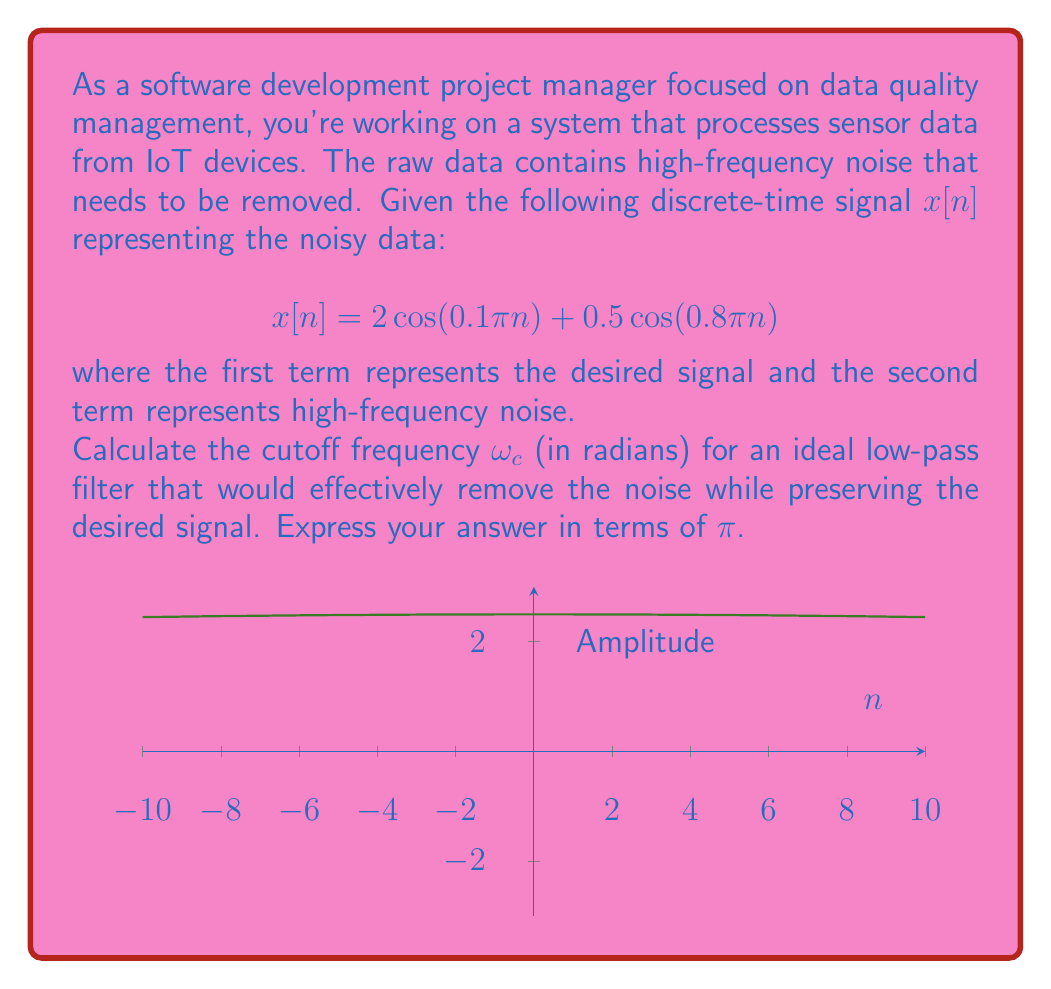What is the answer to this math problem? To solve this problem, we need to follow these steps:

1) Identify the frequencies in the signal:
   - The desired signal has a frequency of $0.1\pi$
   - The noise has a frequency of $0.8\pi$

2) The ideal low-pass filter should allow the lower frequency (desired signal) to pass while blocking the higher frequency (noise).

3) The cutoff frequency $\omega_c$ should be between these two frequencies:

   $$0.1\pi < \omega_c < 0.8\pi$$

4) To ensure we preserve the desired signal and remove the noise, we should choose a cutoff frequency closer to the lower frequency but sufficiently far from the higher frequency.

5) A common practice is to choose the cutoff frequency as the geometric mean of the two frequencies:

   $$\omega_c = \sqrt{(0.1\pi)(0.8\pi)} = \sqrt{0.08\pi^2} = \pi\sqrt{0.08}$$

6) Simplify:
   $$\omega_c = \pi\sqrt{0.08} \approx 0.2827\pi$$

Therefore, a suitable cutoff frequency for the low-pass filter would be approximately $0.2827\pi$ radians.
Answer: $\omega_c = \pi\sqrt{0.08}$ 